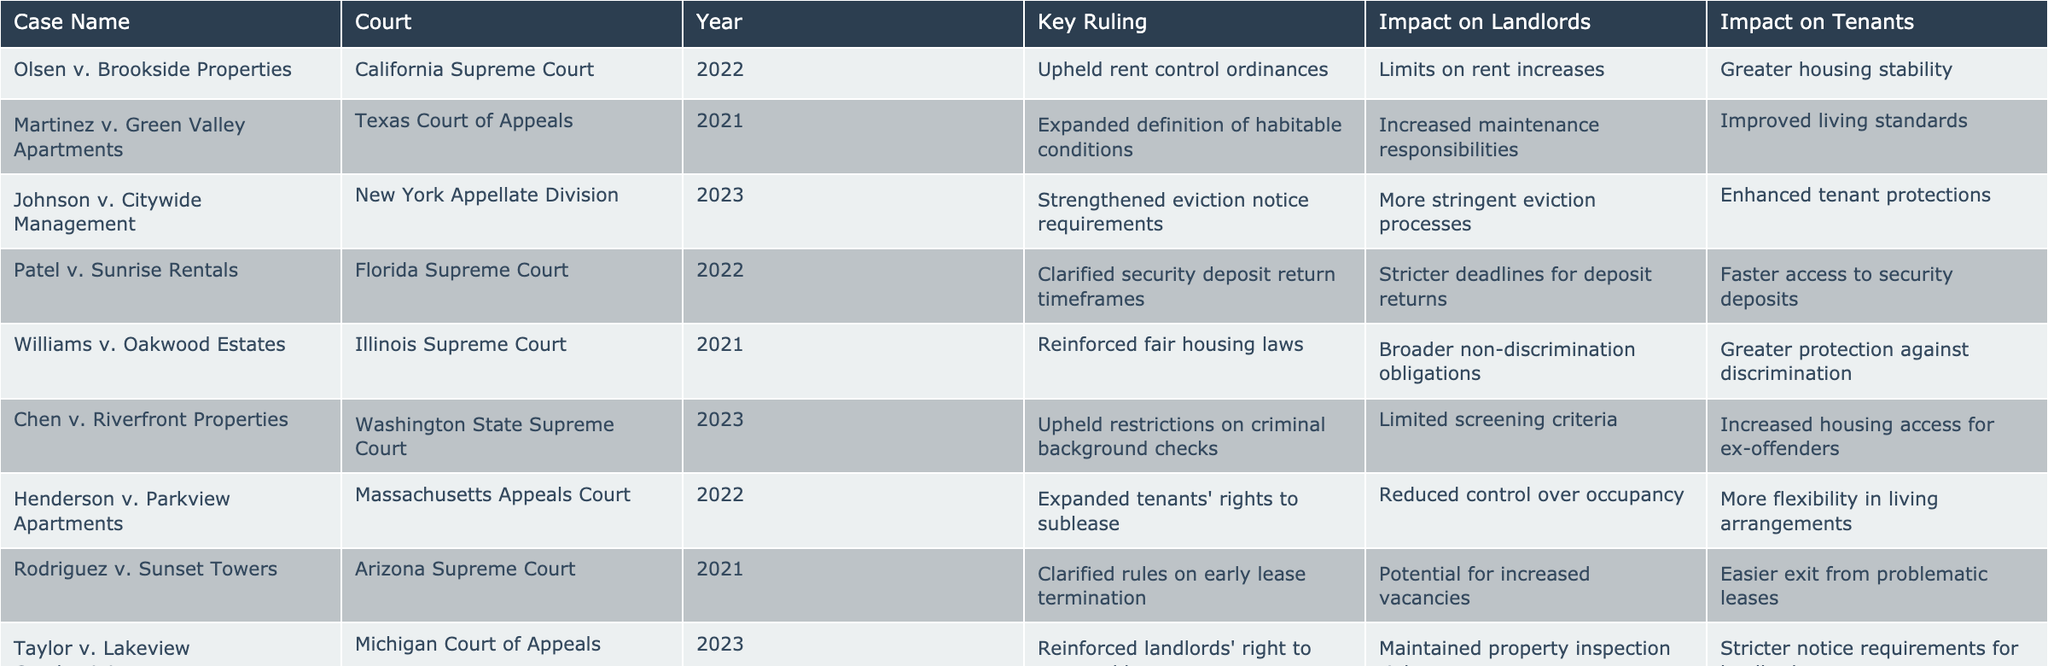What was the key ruling in the case Olsen v. Brookside Properties? The table shows that the key ruling in this case was the upholding of rent control ordinances.
Answer: Upheld rent control ordinances Which court ruled on the case Taylor v. Lakeview Condominiums? According to the table, the Michigan Court of Appeals ruled on the case Taylor v. Lakeview Condominiums.
Answer: Michigan Court of Appeals In which year did the Arizona Supreme Court clarify rules on early lease termination? The table indicates that the Arizona Supreme Court clarified rules on early lease termination in 2021.
Answer: 2021 How many cases had a positive impact on tenants' housing stabilization? The table highlights that there are three cases (Olsen v. Brookside Properties, Johnson v. Citywide Management, and Chen v. Riverfront Properties) that had a positive impact on tenants' housing stabilization.
Answer: 3 Did any rulings expand the definition of habitable conditions? The table confirms that the ruling in Martinez v. Green Valley Apartments expanded the definition of habitable conditions.
Answer: Yes What is the impact on landlords of the ruling in Johnson v. Citywide Management? The table states that the impact on landlords of this ruling is more stringent eviction processes.
Answer: More stringent eviction processes Can you compare the impact on landlords for the cases Brown v. Mountain View Rentals and Olsen v. Brookside Properties? From the table, the impact on landlords in Brown v. Mountain View Rentals includes restrictions on property use, while the impact in Olsen v. Brookside Properties involves limits on rent increases. The first case restricts how properties can be used, whereas the second limits financial gains through rent.
Answer: Different impacts; one is restrictions on property use, the other is limits on rent increases What is the overall trend in recent rulings regarding tenant protections? Analyzing the rulings, a majority (six out of ten) either enhance tenant protections or improve living standards, indicating a trend towards increased tenant rights and protections.
Answer: A trend towards increased tenant protections Which case clarified security deposit return timeframes, and what was its impact on tenants? The table identifies Patel v. Sunrise Rentals as the case that clarified security deposit return timeframes, which allows for faster access to security deposits for tenants.
Answer: Patel v. Sunrise Rentals; faster access to security deposits What is the key difference in impacts on landlords between the cases Williams v. Oakwood Estates and Chen v. Riverfront Properties? In Williams v. Oakwood Estates, the impact on landlords includes broader non-discrimination obligations, while in Chen v. Riverfront Properties, it includes limited screening criteria. The former relates to fair hiring practices, while the latter pertains to tenant screening processes.
Answer: Broader non-discrimination obligations vs. limited screening criteria 